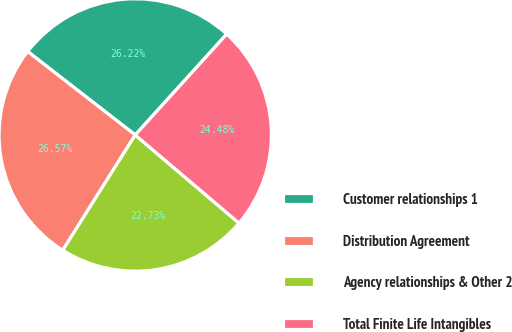Convert chart to OTSL. <chart><loc_0><loc_0><loc_500><loc_500><pie_chart><fcel>Customer relationships 1<fcel>Distribution Agreement<fcel>Agency relationships & Other 2<fcel>Total Finite Life Intangibles<nl><fcel>26.22%<fcel>26.57%<fcel>22.73%<fcel>24.48%<nl></chart> 